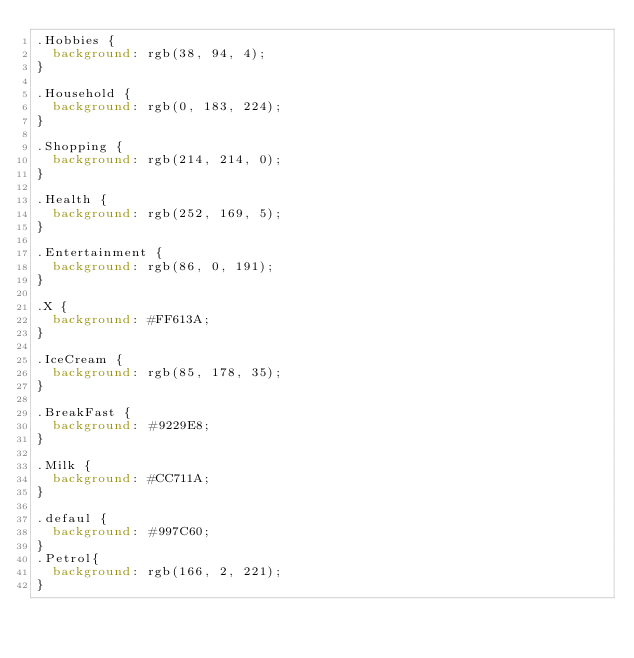<code> <loc_0><loc_0><loc_500><loc_500><_CSS_>.Hobbies {
  background: rgb(38, 94, 4);
}

.Household {
  background: rgb(0, 183, 224);
}

.Shopping {
  background: rgb(214, 214, 0);
}

.Health {
  background: rgb(252, 169, 5);
}

.Entertainment {
  background: rgb(86, 0, 191);
}

.X {
  background: #FF613A;
}

.IceCream {
  background: rgb(85, 178, 35);
}

.BreakFast {
  background: #9229E8;
}

.Milk {
  background: #CC711A;
}

.defaul {
  background: #997C60;
}
.Petrol{
  background: rgb(166, 2, 221);
}</code> 